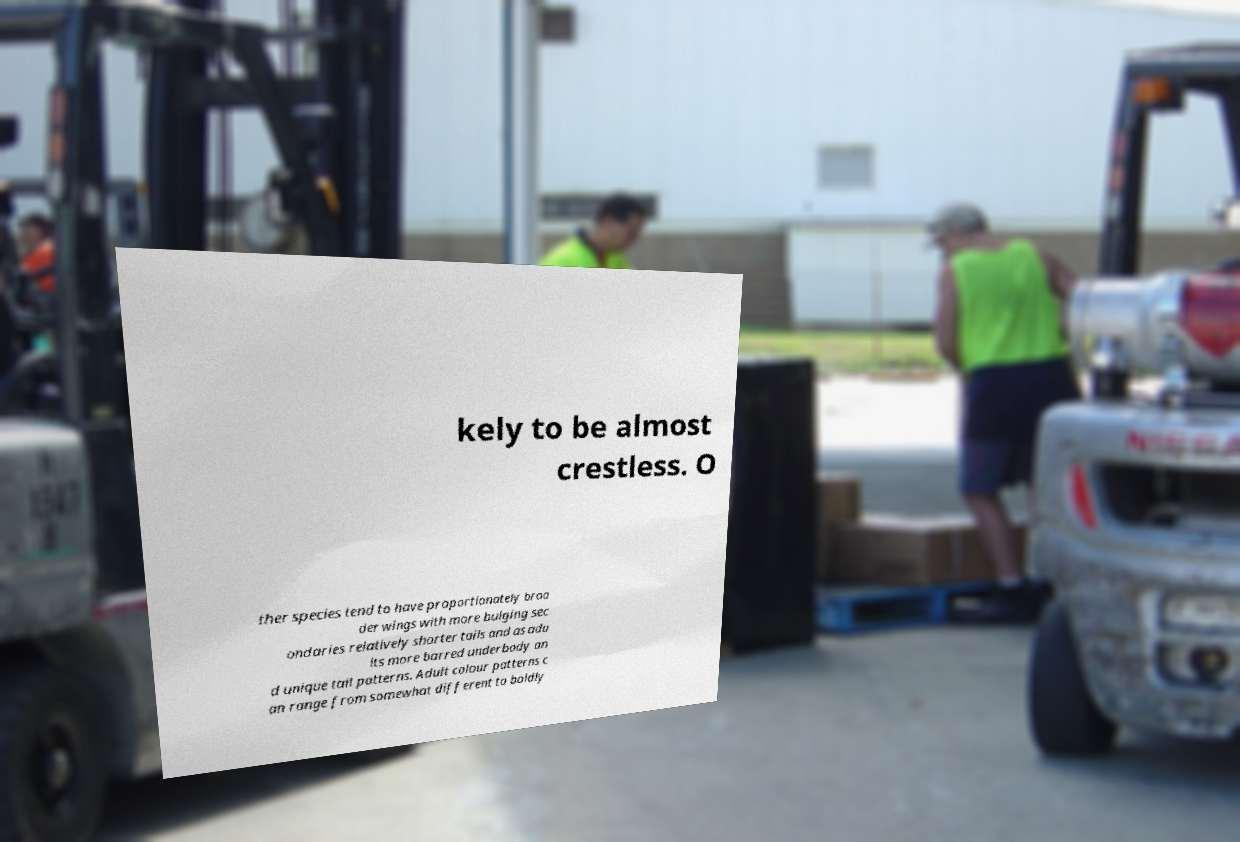Could you extract and type out the text from this image? kely to be almost crestless. O ther species tend to have proportionately broa der wings with more bulging sec ondaries relatively shorter tails and as adu lts more barred underbody an d unique tail patterns. Adult colour patterns c an range from somewhat different to boldly 